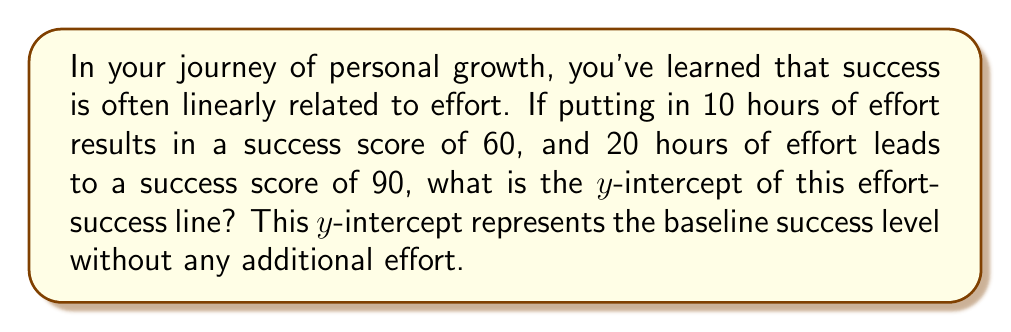Can you solve this math problem? Let's approach this step-by-step:

1) We're given two points on the line:
   (10, 60) and (20, 90)

2) The general equation of a line is:
   $y = mx + b$
   where $m$ is the slope and $b$ is the y-intercept

3) To find the slope:
   $m = \frac{y_2 - y_1}{x_2 - x_1} = \frac{90 - 60}{20 - 10} = \frac{30}{10} = 3$

4) Now we have:
   $y = 3x + b$

5) We can use either point to solve for $b$. Let's use (10, 60):
   $60 = 3(10) + b$
   $60 = 30 + b$
   $b = 60 - 30 = 30$

6) Therefore, the equation of the line is:
   $y = 3x + 30$

7) The y-intercept is the $b$ value, which is 30.

This means that even with zero additional effort (x = 0), there's a baseline success level of 30, perhaps representing innate abilities or environmental factors.
Answer: 30 